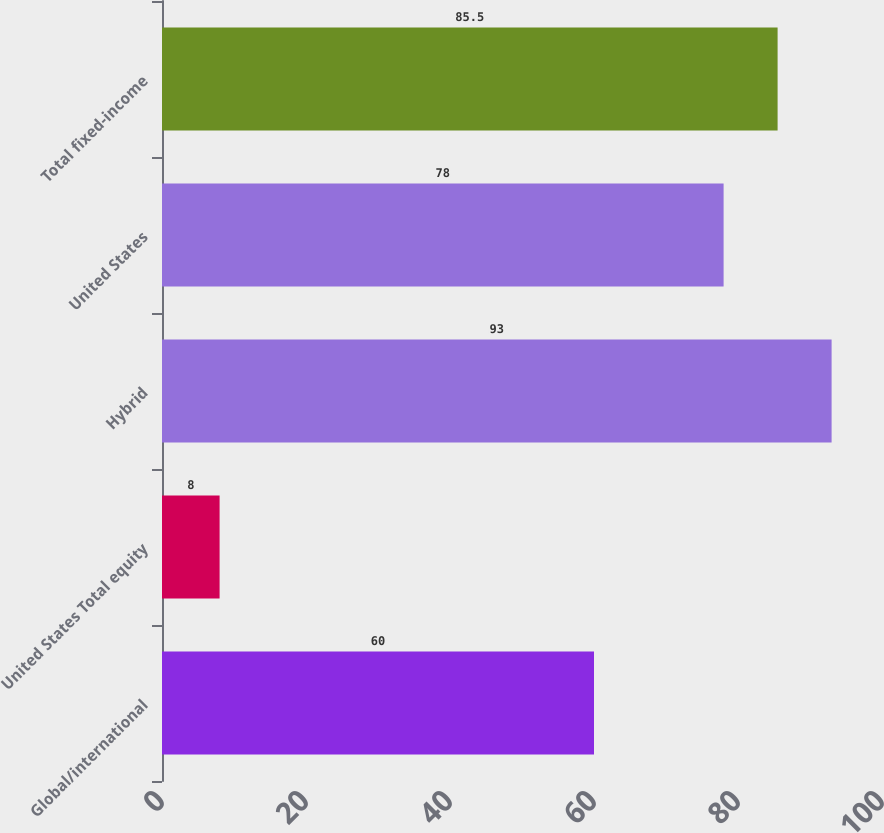Convert chart to OTSL. <chart><loc_0><loc_0><loc_500><loc_500><bar_chart><fcel>Global/international<fcel>United States Total equity<fcel>Hybrid<fcel>United States<fcel>Total fixed-income<nl><fcel>60<fcel>8<fcel>93<fcel>78<fcel>85.5<nl></chart> 